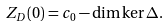Convert formula to latex. <formula><loc_0><loc_0><loc_500><loc_500>Z _ { D } ( 0 ) = c _ { 0 } - \dim \ker \Delta .</formula> 